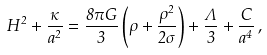<formula> <loc_0><loc_0><loc_500><loc_500>H ^ { 2 } + \frac { \kappa } { a ^ { 2 } } = \frac { 8 \pi G } { 3 } \left ( \rho + \frac { \rho ^ { 2 } } { 2 \sigma } \right ) + \frac { \Lambda } { 3 } + \frac { C } { a ^ { 4 } } \, ,</formula> 